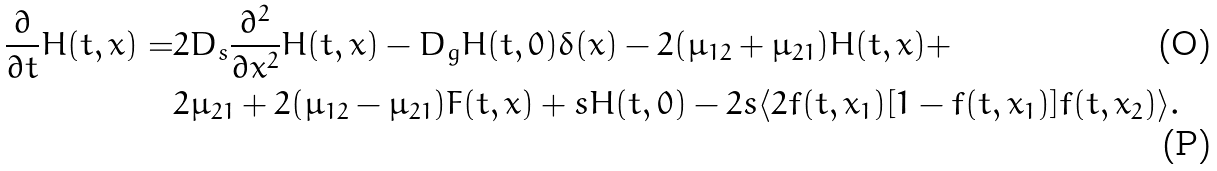Convert formula to latex. <formula><loc_0><loc_0><loc_500><loc_500>\frac { \partial } { \partial t } H ( t , x ) = & 2 D _ { s } \frac { \partial ^ { 2 } } { \partial x ^ { 2 } } H ( t , x ) - D _ { g } H ( t , 0 ) \delta ( x ) - 2 ( \mu _ { 1 2 } + \mu _ { 2 1 } ) H ( t , x ) + \\ & 2 \mu _ { 2 1 } + 2 ( \mu _ { 1 2 } - \mu _ { 2 1 } ) F ( t , x ) + s H ( t , 0 ) - 2 s \langle 2 f ( t , x _ { 1 } ) [ 1 - f ( t , x _ { 1 } ) ] f ( t , x _ { 2 } ) \rangle .</formula> 